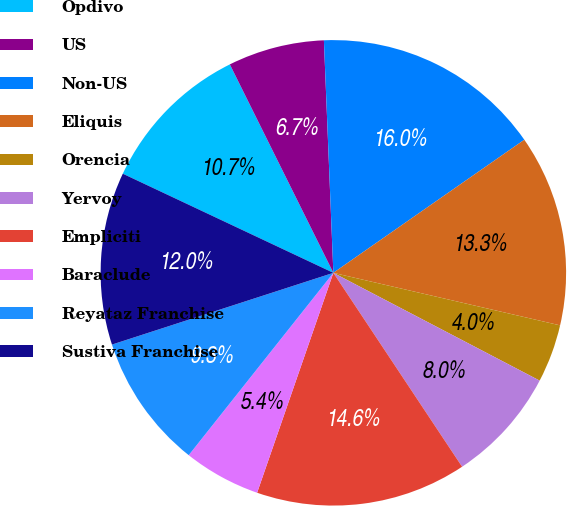Convert chart to OTSL. <chart><loc_0><loc_0><loc_500><loc_500><pie_chart><fcel>Opdivo<fcel>US<fcel>Non-US<fcel>Eliquis<fcel>Orencia<fcel>Yervoy<fcel>Empliciti<fcel>Baraclude<fcel>Reyataz Franchise<fcel>Sustiva Franchise<nl><fcel>10.66%<fcel>6.69%<fcel>15.96%<fcel>13.31%<fcel>4.04%<fcel>8.01%<fcel>14.64%<fcel>5.36%<fcel>9.34%<fcel>11.99%<nl></chart> 